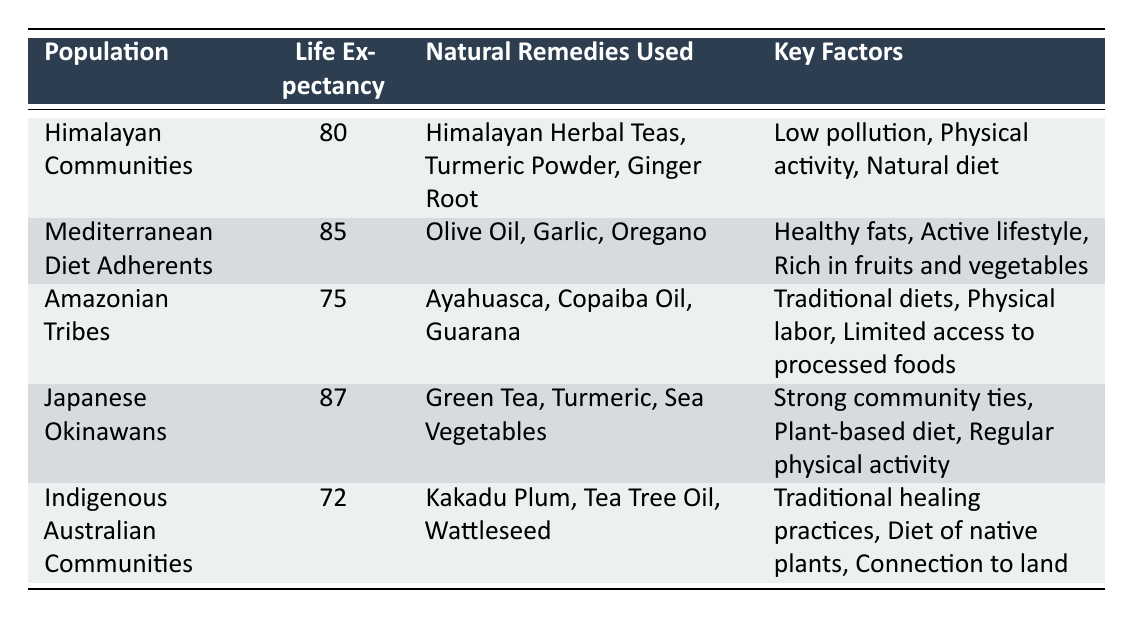What is the average life expectancy of Mediterranean Diet Adherents? The table shows that the average life expectancy for Mediterranean Diet Adherents is listed as 85.
Answer: 85 What natural remedies are used by Himalayan Communities? According to the table, Himalayan Communities use Himalayan Herbal Teas, Turmeric Powder, and Ginger Root as their natural remedies.
Answer: Himalayan Herbal Teas, Turmeric Powder, Ginger Root Is the life expectancy of Indigenous Australian Communities higher than that of Amazonian Tribes? The table indicates that Indigenous Australian Communities have an average life expectancy of 72, while Amazonian Tribes have a life expectancy of 75. Therefore, the statement is false.
Answer: No Which population has the highest average life expectancy? By examining the life expectancy values, we can see that Japanese Okinawans have the highest average life expectancy, listed at 87.
Answer: Japanese Okinawans What are the key factors that contribute to the average life expectancy of Japanese Okinawans? The table highlights that the key factors for Japanese Okinawans include strong community ties, a plant-based diet, and regular physical activity.
Answer: Strong community ties, plant-based diet, regular physical activity Calculate the difference in life expectancy between the population with the highest and lowest life expectancy. The highest life expectancy is 87 (Japanese Okinawans) and the lowest is 72 (Indigenous Australian Communities). The difference is calculated as 87 - 72 = 15.
Answer: 15 Do Amazonian Tribes use any of the same natural remedies as Himalayan Communities? Reviewing the natural remedies used, Amazonian Tribes use Ayahuasca, Copaiba Oil, and Guarana, which are different from Himalayan Communities' remedies. Therefore, the answer is no.
Answer: No What is the average life expectancy for the populations that use Turmeric? Turmeric is used by both Himalayan Communities (80) and Japanese Okinawans (87). The average life expectancy can be calculated as (80 + 87) / 2 = 83.5.
Answer: 83.5 Are the key factors for Indigenous Australian Communities related to their environment? The key factors listed include traditional healing practices, diet of native plants, and connection to land, which are indeed related to their environment, indicating that the statement is true.
Answer: Yes 